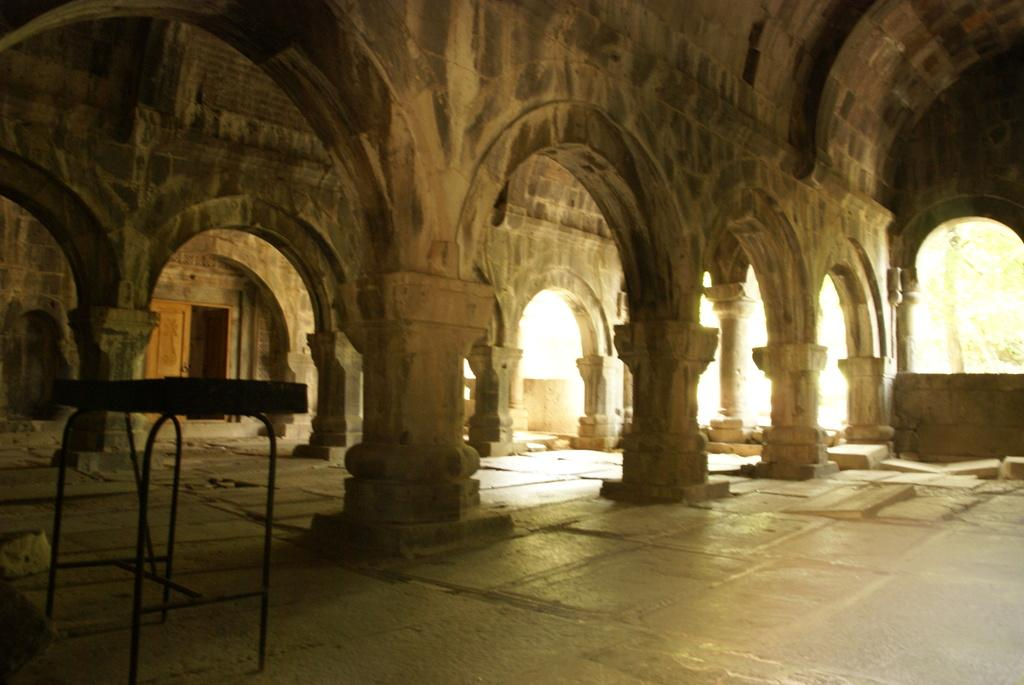What type of structure is depicted in the image? There is an arch construction in the image. What architectural elements support the arch construction? There are pillars in the image. What is the main object in the image? There is an object in the image. What surface is visible in the image? There is a floor in the image. What allows natural light to enter the space in the image? There is a window in the image. Can you see any yard or lake in the image? No, there is no yard or lake present in the image. What type of picture is hanging on the wall in the image? There is no mention of a picture or a wall in the image, so it cannot be determined. 